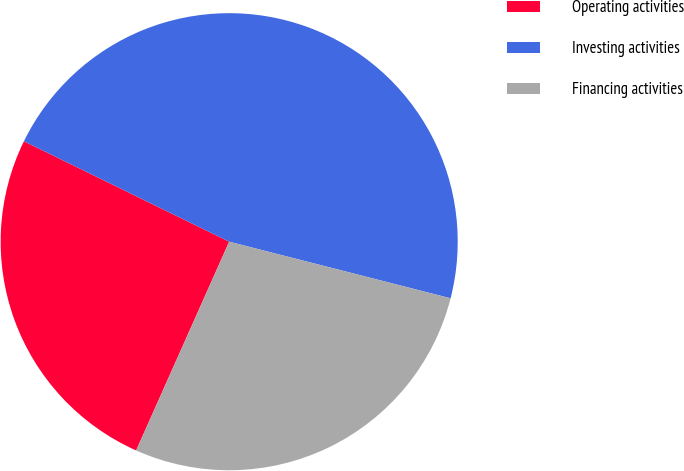<chart> <loc_0><loc_0><loc_500><loc_500><pie_chart><fcel>Operating activities<fcel>Investing activities<fcel>Financing activities<nl><fcel>25.57%<fcel>46.74%<fcel>27.69%<nl></chart> 